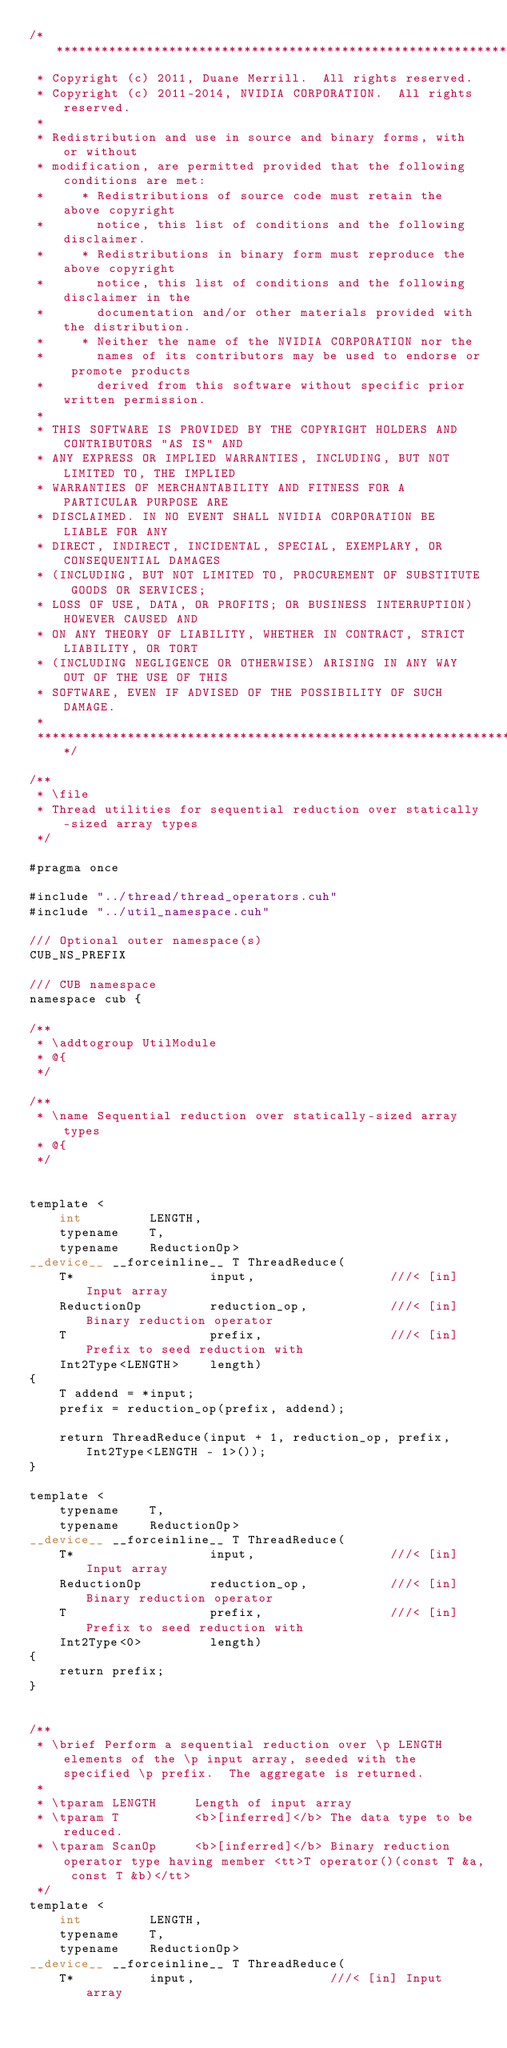<code> <loc_0><loc_0><loc_500><loc_500><_Cuda_>/******************************************************************************
 * Copyright (c) 2011, Duane Merrill.  All rights reserved.
 * Copyright (c) 2011-2014, NVIDIA CORPORATION.  All rights reserved.
 * 
 * Redistribution and use in source and binary forms, with or without
 * modification, are permitted provided that the following conditions are met:
 *     * Redistributions of source code must retain the above copyright
 *       notice, this list of conditions and the following disclaimer.
 *     * Redistributions in binary form must reproduce the above copyright
 *       notice, this list of conditions and the following disclaimer in the
 *       documentation and/or other materials provided with the distribution.
 *     * Neither the name of the NVIDIA CORPORATION nor the
 *       names of its contributors may be used to endorse or promote products
 *       derived from this software without specific prior written permission.
 * 
 * THIS SOFTWARE IS PROVIDED BY THE COPYRIGHT HOLDERS AND CONTRIBUTORS "AS IS" AND
 * ANY EXPRESS OR IMPLIED WARRANTIES, INCLUDING, BUT NOT LIMITED TO, THE IMPLIED
 * WARRANTIES OF MERCHANTABILITY AND FITNESS FOR A PARTICULAR PURPOSE ARE
 * DISCLAIMED. IN NO EVENT SHALL NVIDIA CORPORATION BE LIABLE FOR ANY
 * DIRECT, INDIRECT, INCIDENTAL, SPECIAL, EXEMPLARY, OR CONSEQUENTIAL DAMAGES
 * (INCLUDING, BUT NOT LIMITED TO, PROCUREMENT OF SUBSTITUTE GOODS OR SERVICES;
 * LOSS OF USE, DATA, OR PROFITS; OR BUSINESS INTERRUPTION) HOWEVER CAUSED AND
 * ON ANY THEORY OF LIABILITY, WHETHER IN CONTRACT, STRICT LIABILITY, OR TORT
 * (INCLUDING NEGLIGENCE OR OTHERWISE) ARISING IN ANY WAY OUT OF THE USE OF THIS
 * SOFTWARE, EVEN IF ADVISED OF THE POSSIBILITY OF SUCH DAMAGE.
 *
 ******************************************************************************/

/**
 * \file
 * Thread utilities for sequential reduction over statically-sized array types
 */

#pragma once

#include "../thread/thread_operators.cuh"
#include "../util_namespace.cuh"

/// Optional outer namespace(s)
CUB_NS_PREFIX

/// CUB namespace
namespace cub {

/**
 * \addtogroup UtilModule
 * @{
 */

/**
 * \name Sequential reduction over statically-sized array types
 * @{
 */


template <
    int         LENGTH,
    typename    T,
    typename    ReductionOp>
__device__ __forceinline__ T ThreadReduce(
    T*                  input,                  ///< [in] Input array
    ReductionOp         reduction_op,           ///< [in] Binary reduction operator
    T                   prefix,                 ///< [in] Prefix to seed reduction with
    Int2Type<LENGTH>    length)
{
    T addend = *input;
    prefix = reduction_op(prefix, addend);

    return ThreadReduce(input + 1, reduction_op, prefix, Int2Type<LENGTH - 1>());
}

template <
    typename    T,
    typename    ReductionOp>
__device__ __forceinline__ T ThreadReduce(
    T*                  input,                  ///< [in] Input array
    ReductionOp         reduction_op,           ///< [in] Binary reduction operator
    T                   prefix,                 ///< [in] Prefix to seed reduction with
    Int2Type<0>         length)
{
    return prefix;
}


/**
 * \brief Perform a sequential reduction over \p LENGTH elements of the \p input array, seeded with the specified \p prefix.  The aggregate is returned.
 *
 * \tparam LENGTH     Length of input array
 * \tparam T          <b>[inferred]</b> The data type to be reduced.
 * \tparam ScanOp     <b>[inferred]</b> Binary reduction operator type having member <tt>T operator()(const T &a, const T &b)</tt>
 */
template <
    int         LENGTH,
    typename    T,
    typename    ReductionOp>
__device__ __forceinline__ T ThreadReduce(
    T*          input,                  ///< [in] Input array</code> 